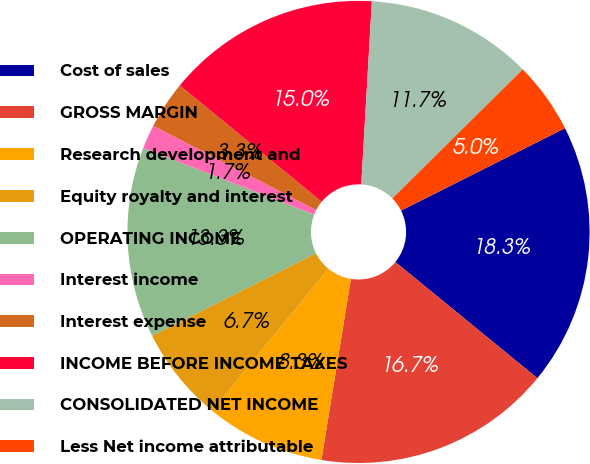Convert chart. <chart><loc_0><loc_0><loc_500><loc_500><pie_chart><fcel>Cost of sales<fcel>GROSS MARGIN<fcel>Research development and<fcel>Equity royalty and interest<fcel>OPERATING INCOME<fcel>Interest income<fcel>Interest expense<fcel>INCOME BEFORE INCOME TAXES<fcel>CONSOLIDATED NET INCOME<fcel>Less Net income attributable<nl><fcel>18.32%<fcel>16.66%<fcel>8.34%<fcel>6.67%<fcel>13.33%<fcel>1.68%<fcel>3.34%<fcel>14.99%<fcel>11.66%<fcel>5.01%<nl></chart> 